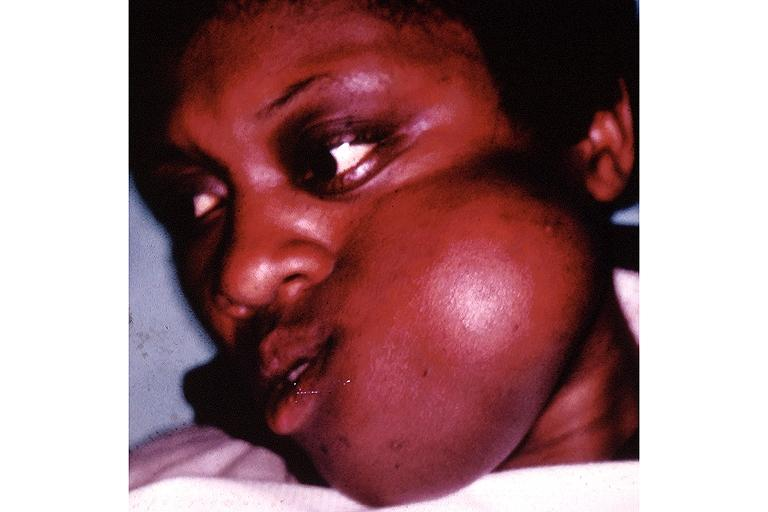what does this image show?
Answer the question using a single word or phrase. Fibrous dysplasia 